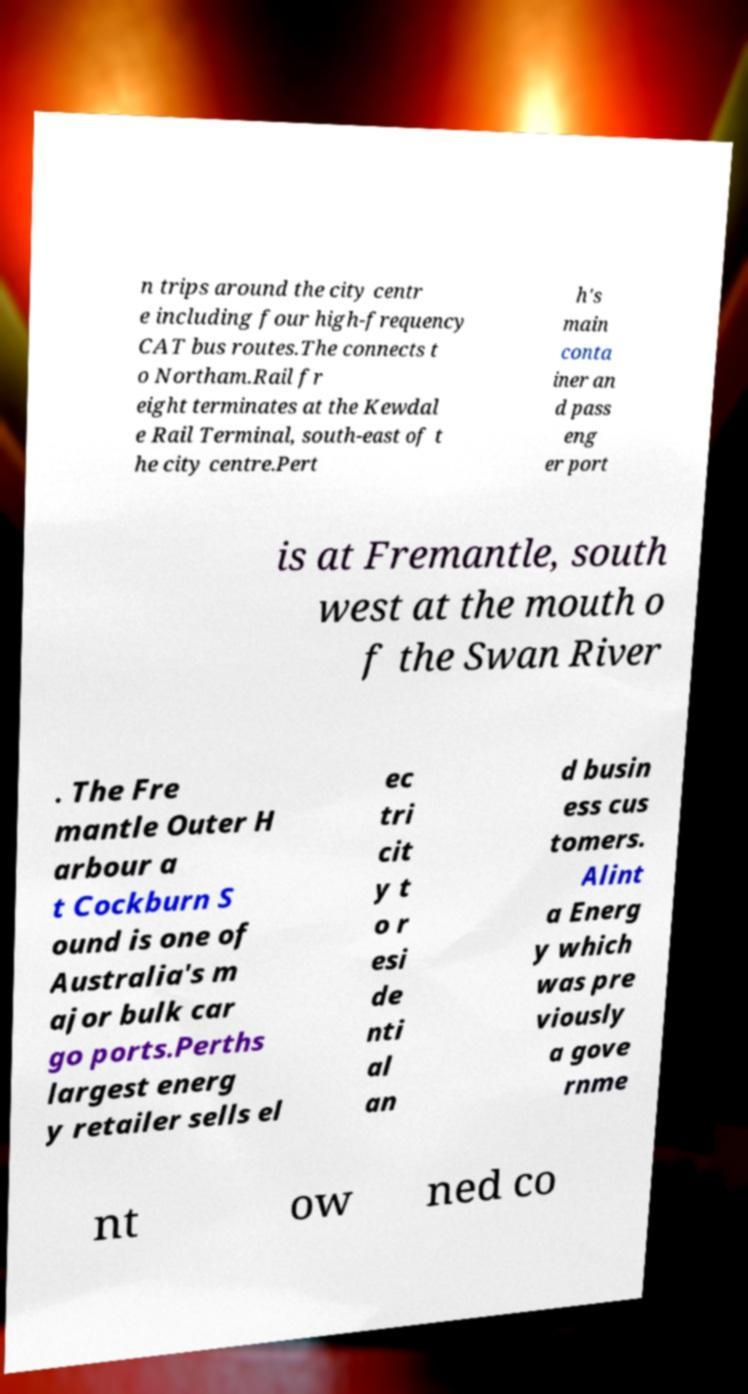For documentation purposes, I need the text within this image transcribed. Could you provide that? n trips around the city centr e including four high-frequency CAT bus routes.The connects t o Northam.Rail fr eight terminates at the Kewdal e Rail Terminal, south-east of t he city centre.Pert h's main conta iner an d pass eng er port is at Fremantle, south west at the mouth o f the Swan River . The Fre mantle Outer H arbour a t Cockburn S ound is one of Australia's m ajor bulk car go ports.Perths largest energ y retailer sells el ec tri cit y t o r esi de nti al an d busin ess cus tomers. Alint a Energ y which was pre viously a gove rnme nt ow ned co 